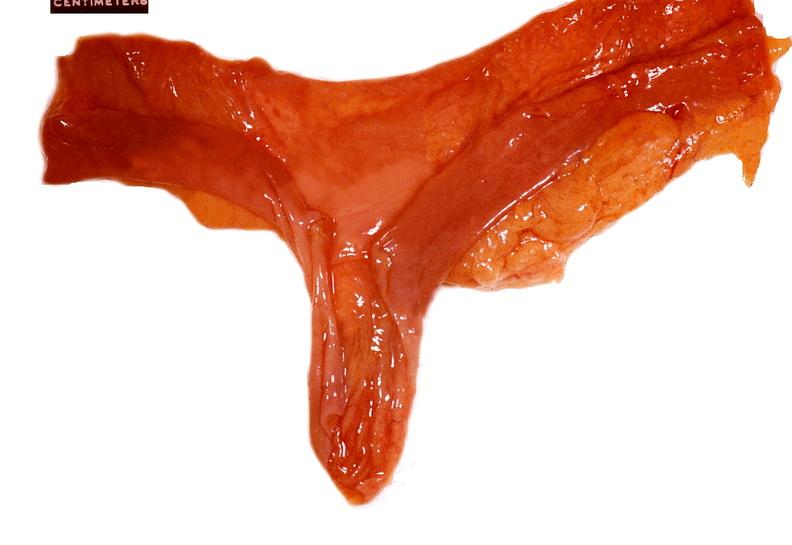does gout show small intestine, meckels diverticulum?
Answer the question using a single word or phrase. No 